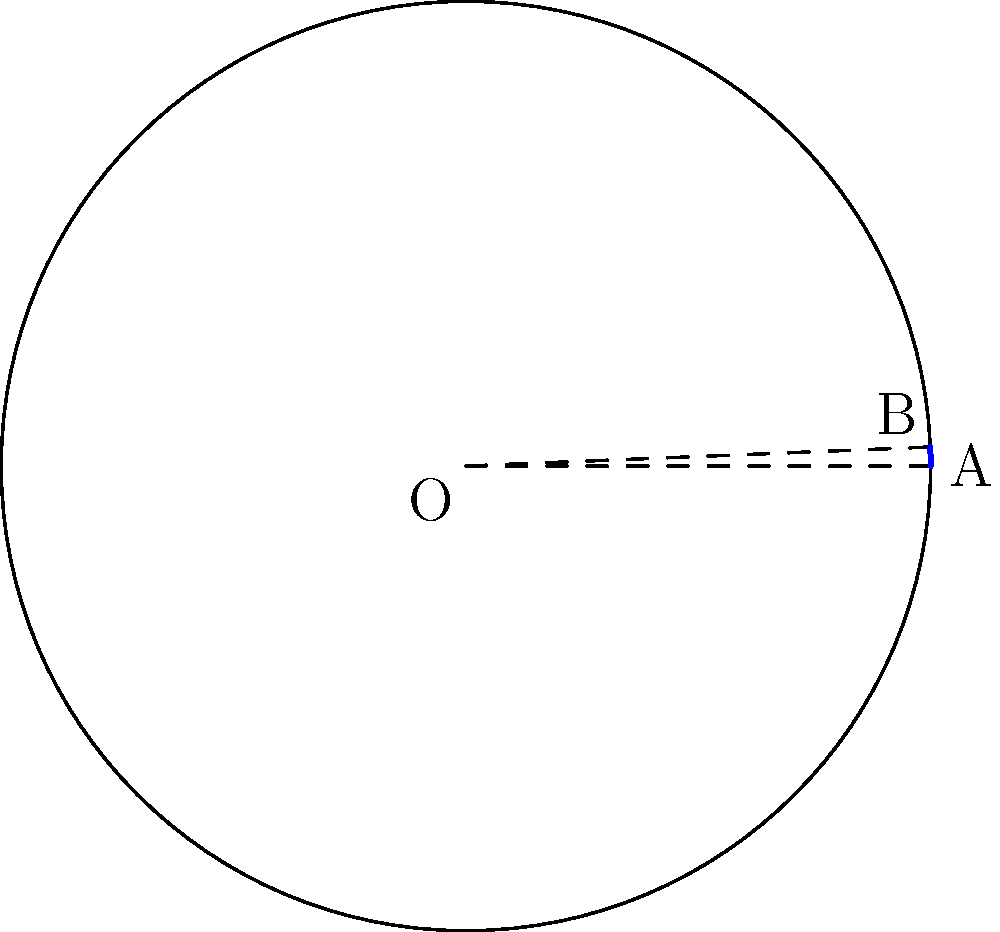You are designing a circular brooch inspired by the Jellinge style, with a radius of 6 cm. If an arc of the brooch spans an angle of 135°, what is the length of this arc to the nearest millimeter? To find the length of the arc, we'll follow these steps:

1) Recall the formula for arc length: $s = r\theta$
   Where $s$ is the arc length, $r$ is the radius, and $\theta$ is the central angle in radians.

2) We're given the radius $r = 6$ cm and the angle of 135°.

3) Convert the angle from degrees to radians:
   $\theta = 135° \times \frac{\pi}{180°} = \frac{3\pi}{4}$ radians

4) Now we can substitute these values into our formula:
   $s = r\theta = 6 \times \frac{3\pi}{4}$

5) Simplify:
   $s = \frac{9\pi}{2} \approx 14.137$ cm

6) Rounding to the nearest millimeter:
   $s \approx 14.1$ cm or 141 mm
Answer: 141 mm 